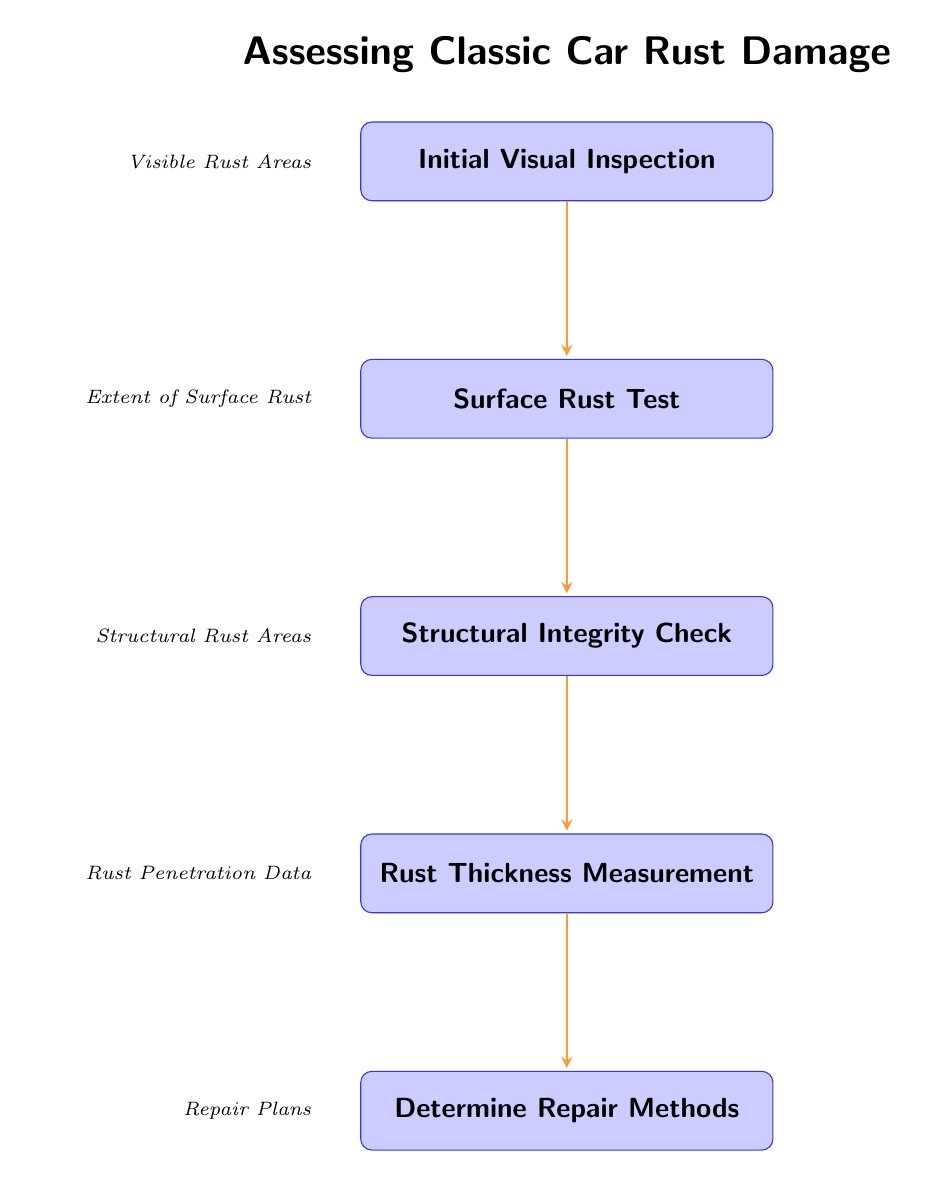What is the first step in assessing rust damage? The first node in the flow chart outlines the initial action taken, which is "Initial Visual Inspection." This is the starting point for assessing rust damage.
Answer: Initial Visual Inspection How many steps are there in total? By counting the numbered nodes in the flow chart, we find there are five steps listed from the "Initial Visual Inspection" to "Determine Repair Methods."
Answer: 5 What is the output of the "Surface Rust Test"? The output specified for the "Surface Rust Test" node is "Extent of Surface Rust." This is directly linked to the execution of that step.
Answer: Extent of Surface Rust Which step follows the "Rust Thickness Measurement"? The flow diagram indicates that "Determine Repair Methods" comes directly after "Rust Thickness Measurement," establishing a sequential relationship.
Answer: Determine Repair Methods What are the outputs for the last two steps combined? The outputs for "Rust Thickness Measurement" and "Determine Repair Methods" are "Rust Penetration Data" and "Repair Plans," respectively. These represent the conclusions of the assessment flow.
Answer: Rust Penetration Data, Repair Plans What step involves using tools like a metal thickness gauge? The node detailing the use of a metal thickness gauge corresponds to the "Rust Thickness Measurement" step, which specifically addresses this action in the assessment process.
Answer: Rust Thickness Measurement How is "Structural Integrity Check" related to "Initial Visual Inspection"? The flow chart indicates a direct progression from "Initial Visual Inspection" to "Structural Integrity Check," showing that the initial assessment leads directly to evaluating structural aspects.
Answer: Direct progression What method is evaluated after identifying "Structural Rust Areas"? After determining "Structural Rust Areas," the subsequent step in the flow chart is "Rust Thickness Measurement," which follows directly after the structural integrity check in the assessment process.
Answer: Rust Thickness Measurement Which step focuses on visible rust spots? The "Initial Visual Inspection" step specifically targets the identification of visible rust, highlighting its importance as the opening step in the assessment process.
Answer: Initial Visual Inspection 